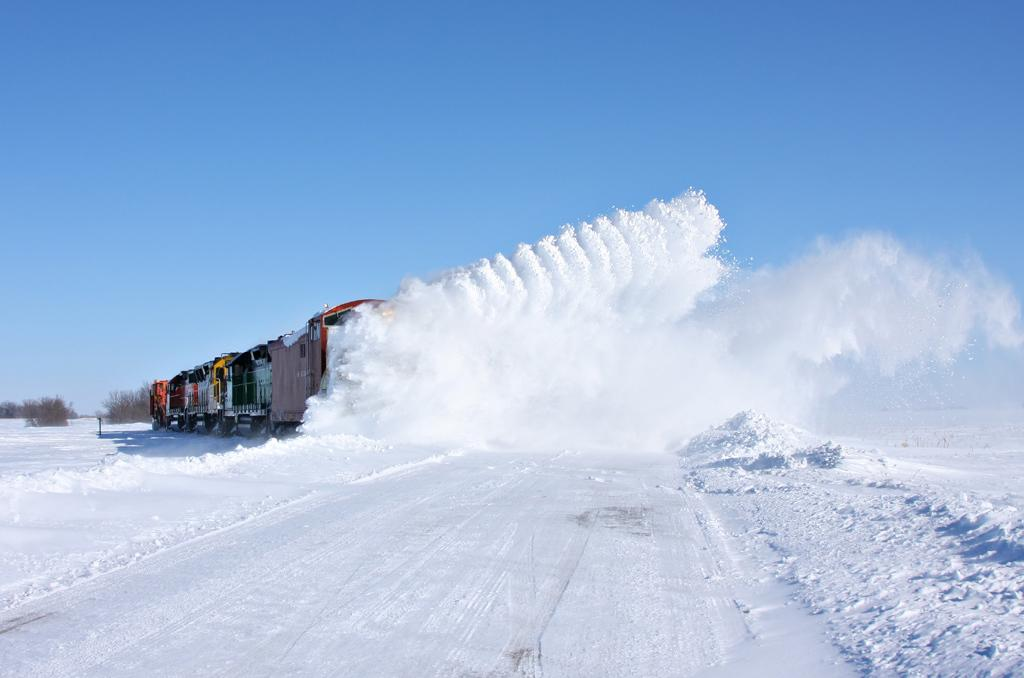What is the main feature of the image? The main feature of the image is snow. How is the snow behaving in the image? The snow is flowing upward in the image. What else can be seen in the image besides the snow? A train is passing through the snow in the image. What is visible at the top of the image? The sky is visible at the top of the image. What type of belief is being expressed in the image? There is no indication of any beliefs being expressed in the image; it primarily features snow and a train. Can you read any writing on the train in the image? There is no visible writing on the train in the image. 